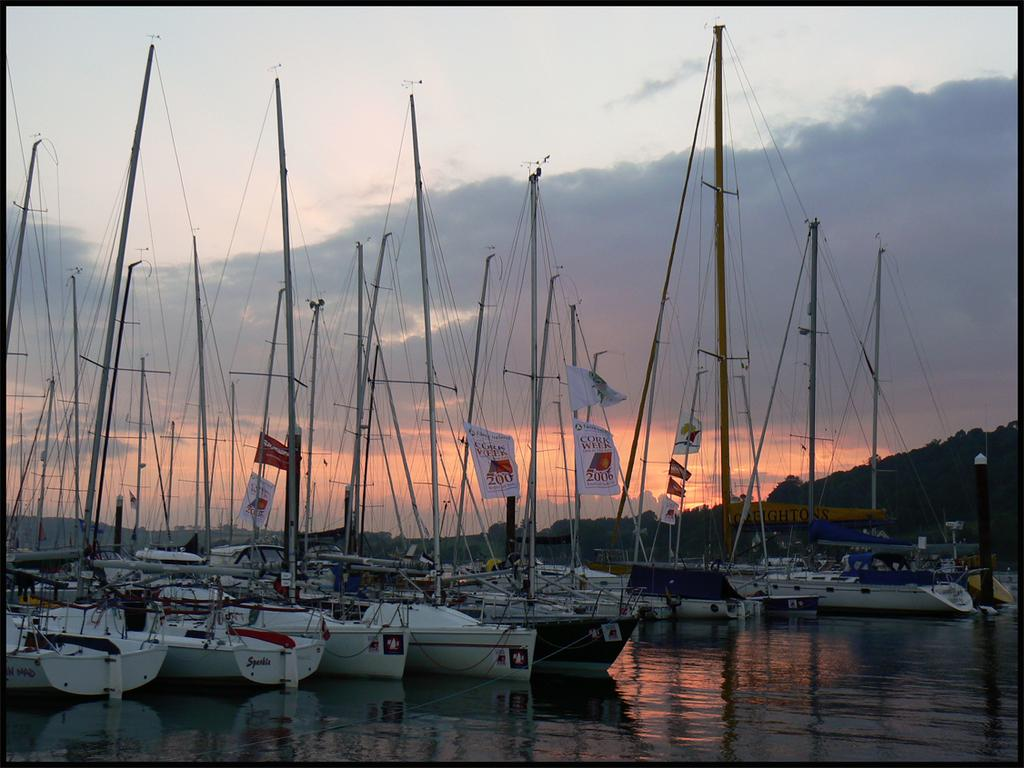Provide a one-sentence caption for the provided image. a lot of boats with a sign saying cork week 2016 ON A BANNER. 